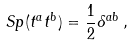<formula> <loc_0><loc_0><loc_500><loc_500>S p ( t ^ { a } t ^ { b } ) = \frac { 1 } { 2 } \delta ^ { a b } \, ,</formula> 